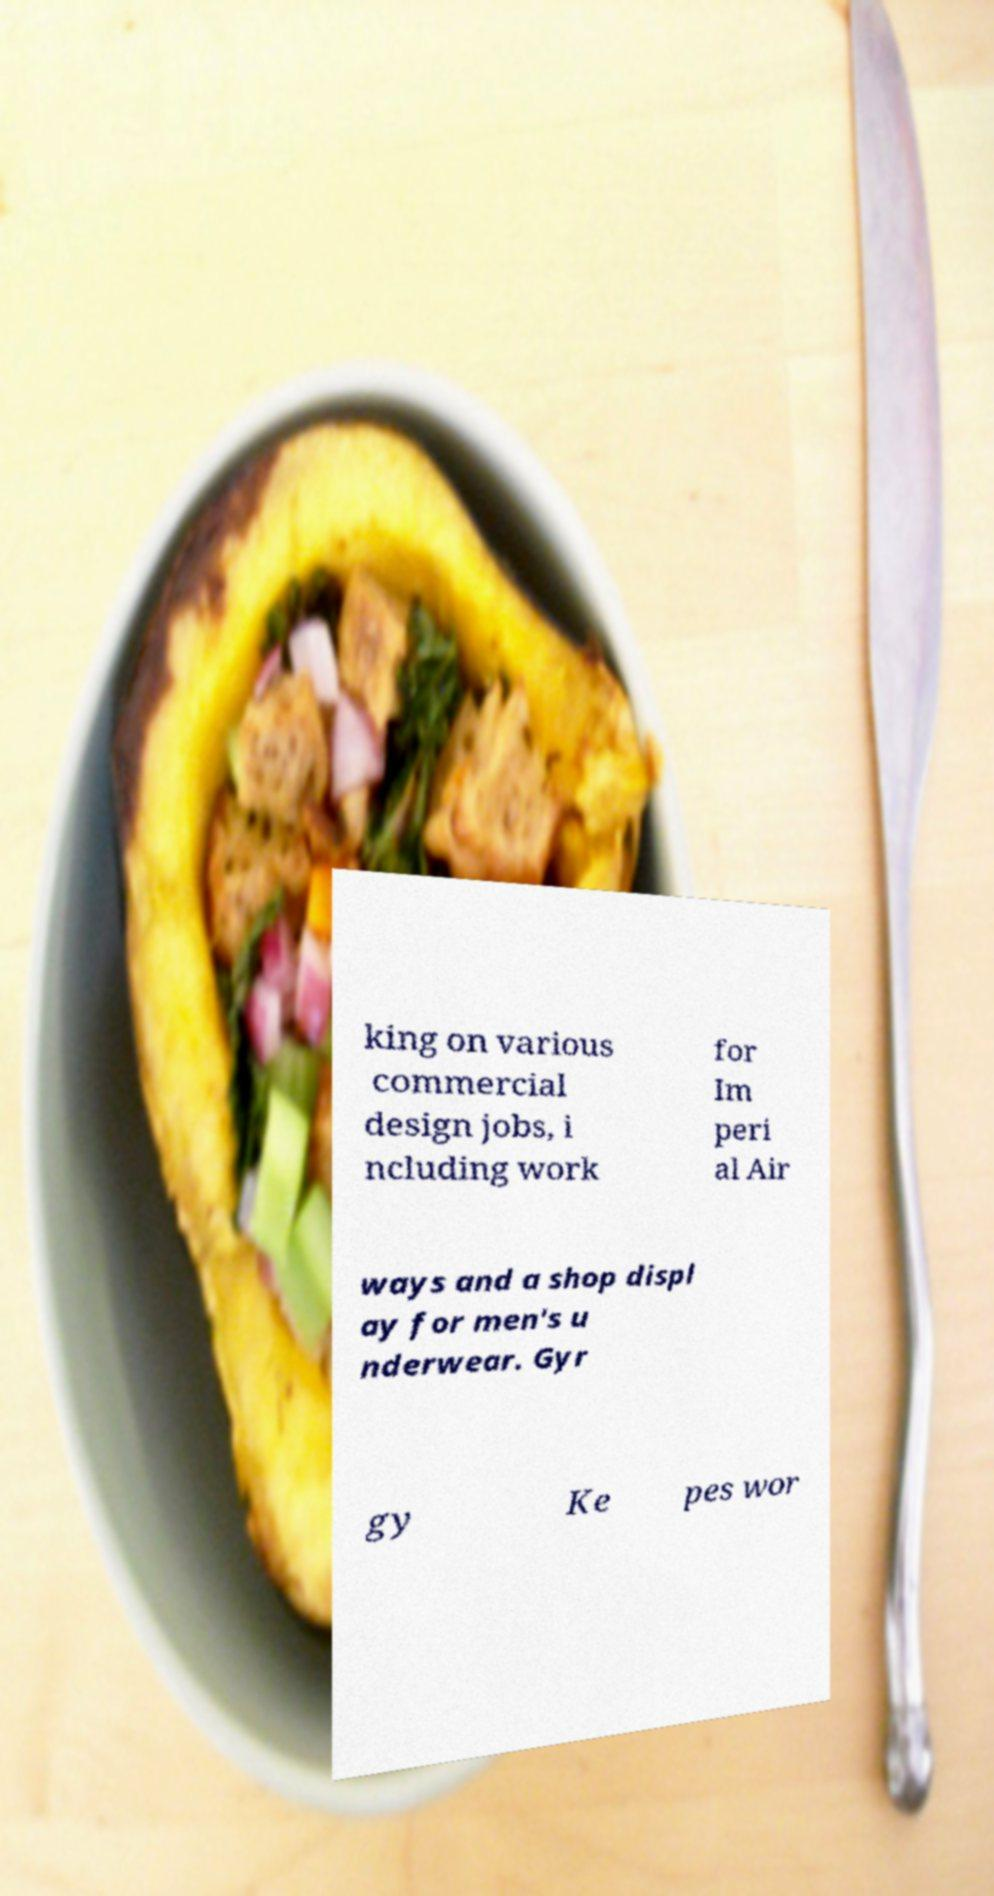I need the written content from this picture converted into text. Can you do that? king on various commercial design jobs, i ncluding work for Im peri al Air ways and a shop displ ay for men's u nderwear. Gyr gy Ke pes wor 